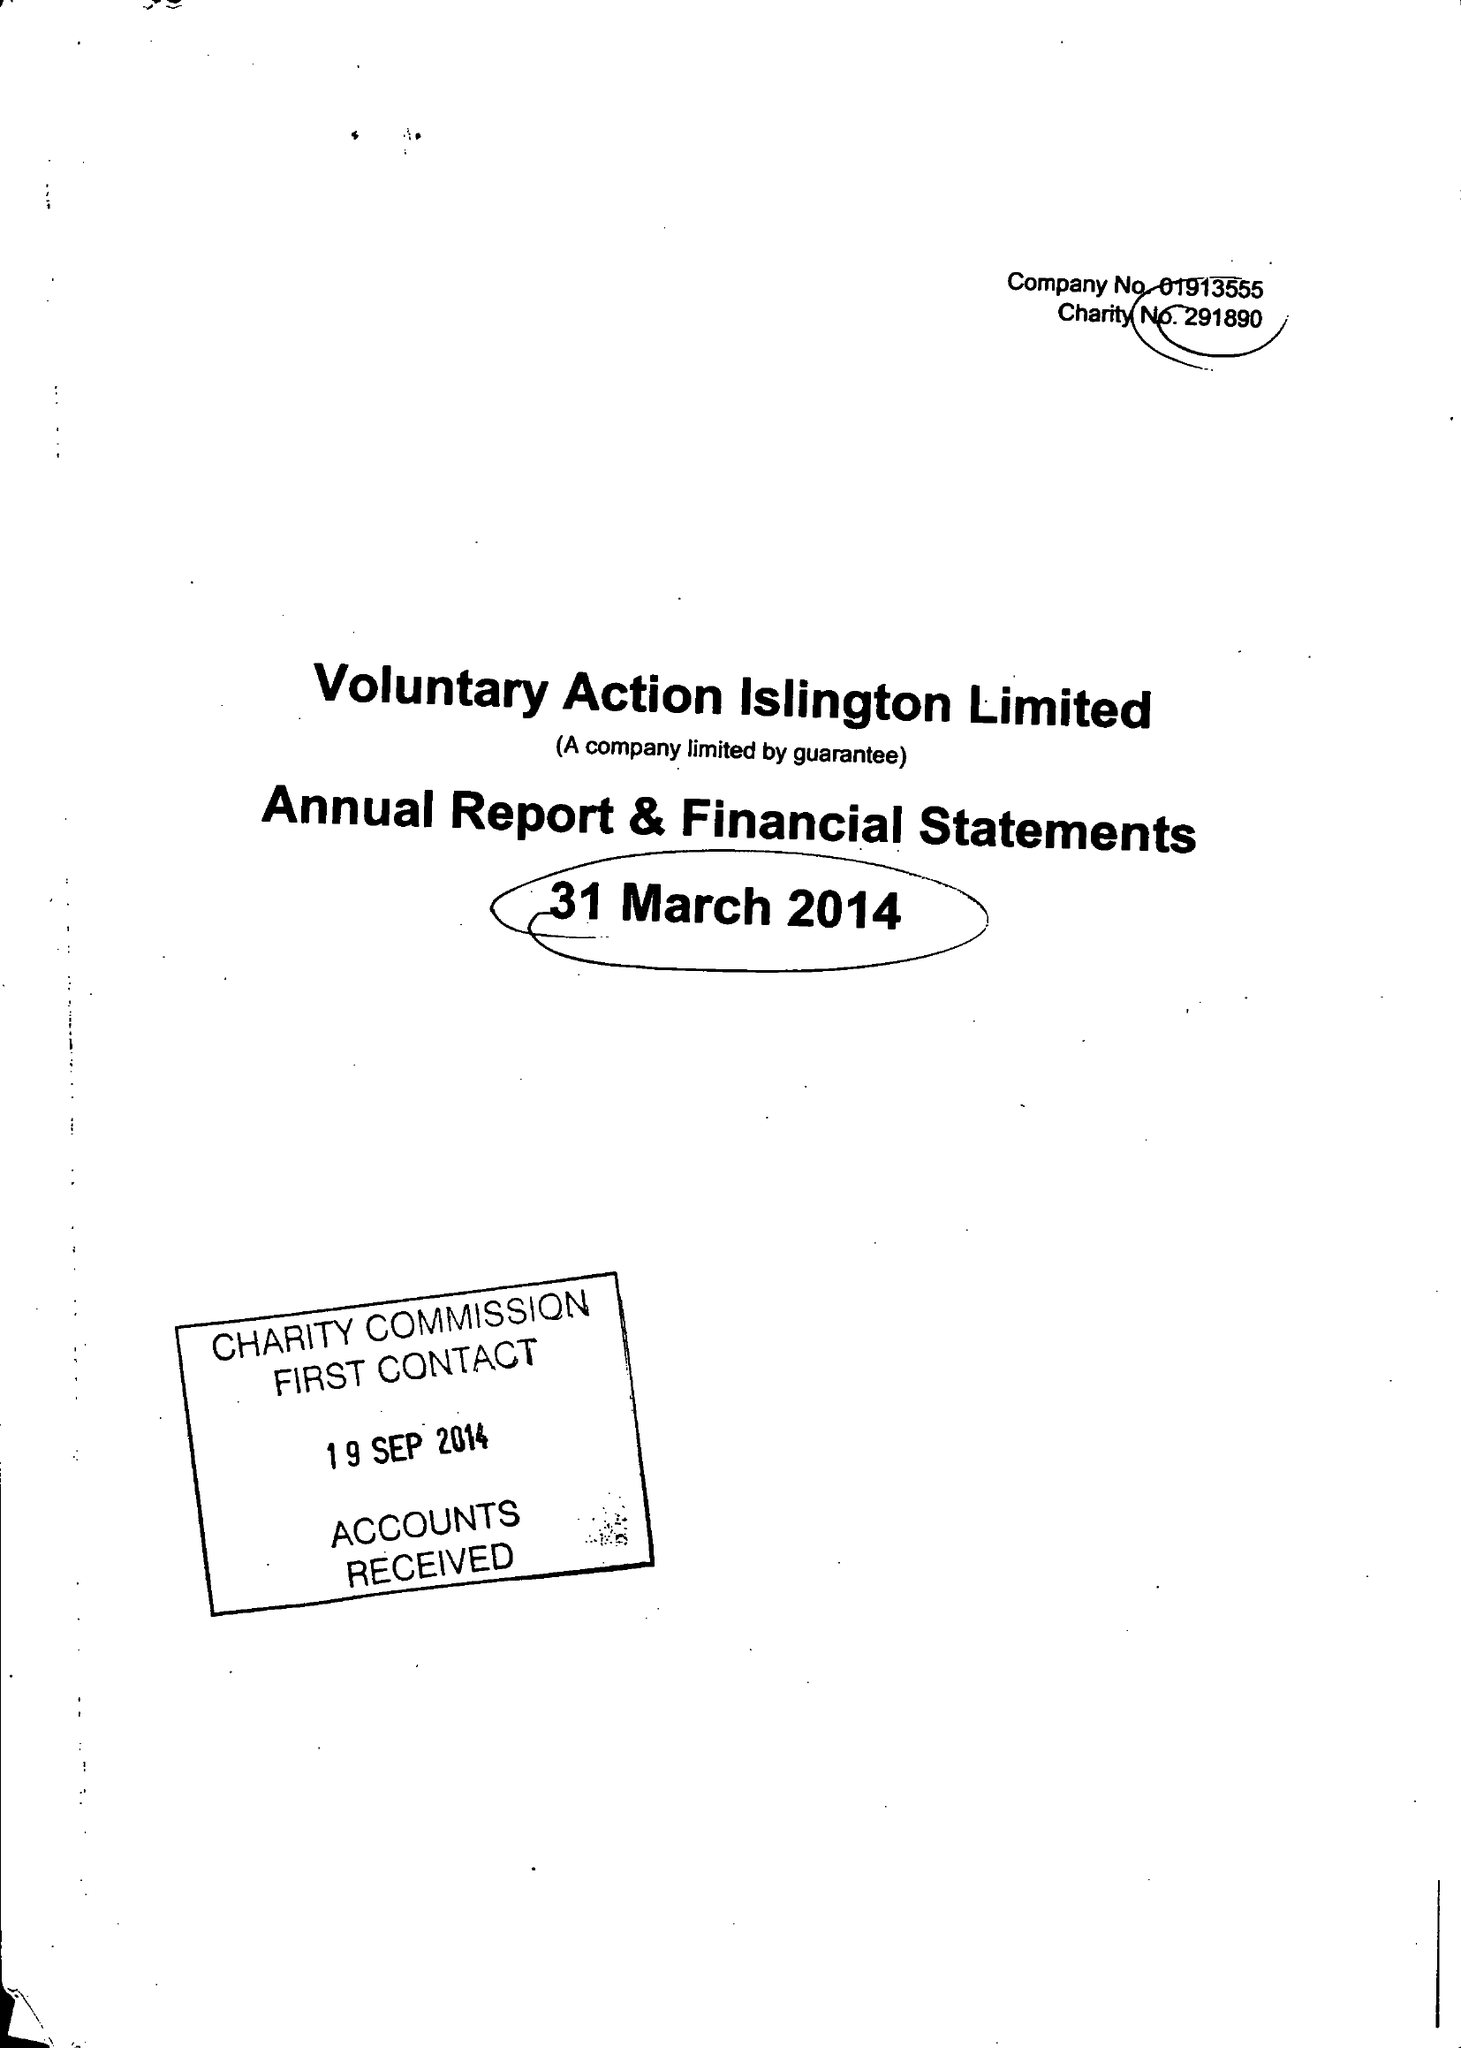What is the value for the spending_annually_in_british_pounds?
Answer the question using a single word or phrase. 547767.00 